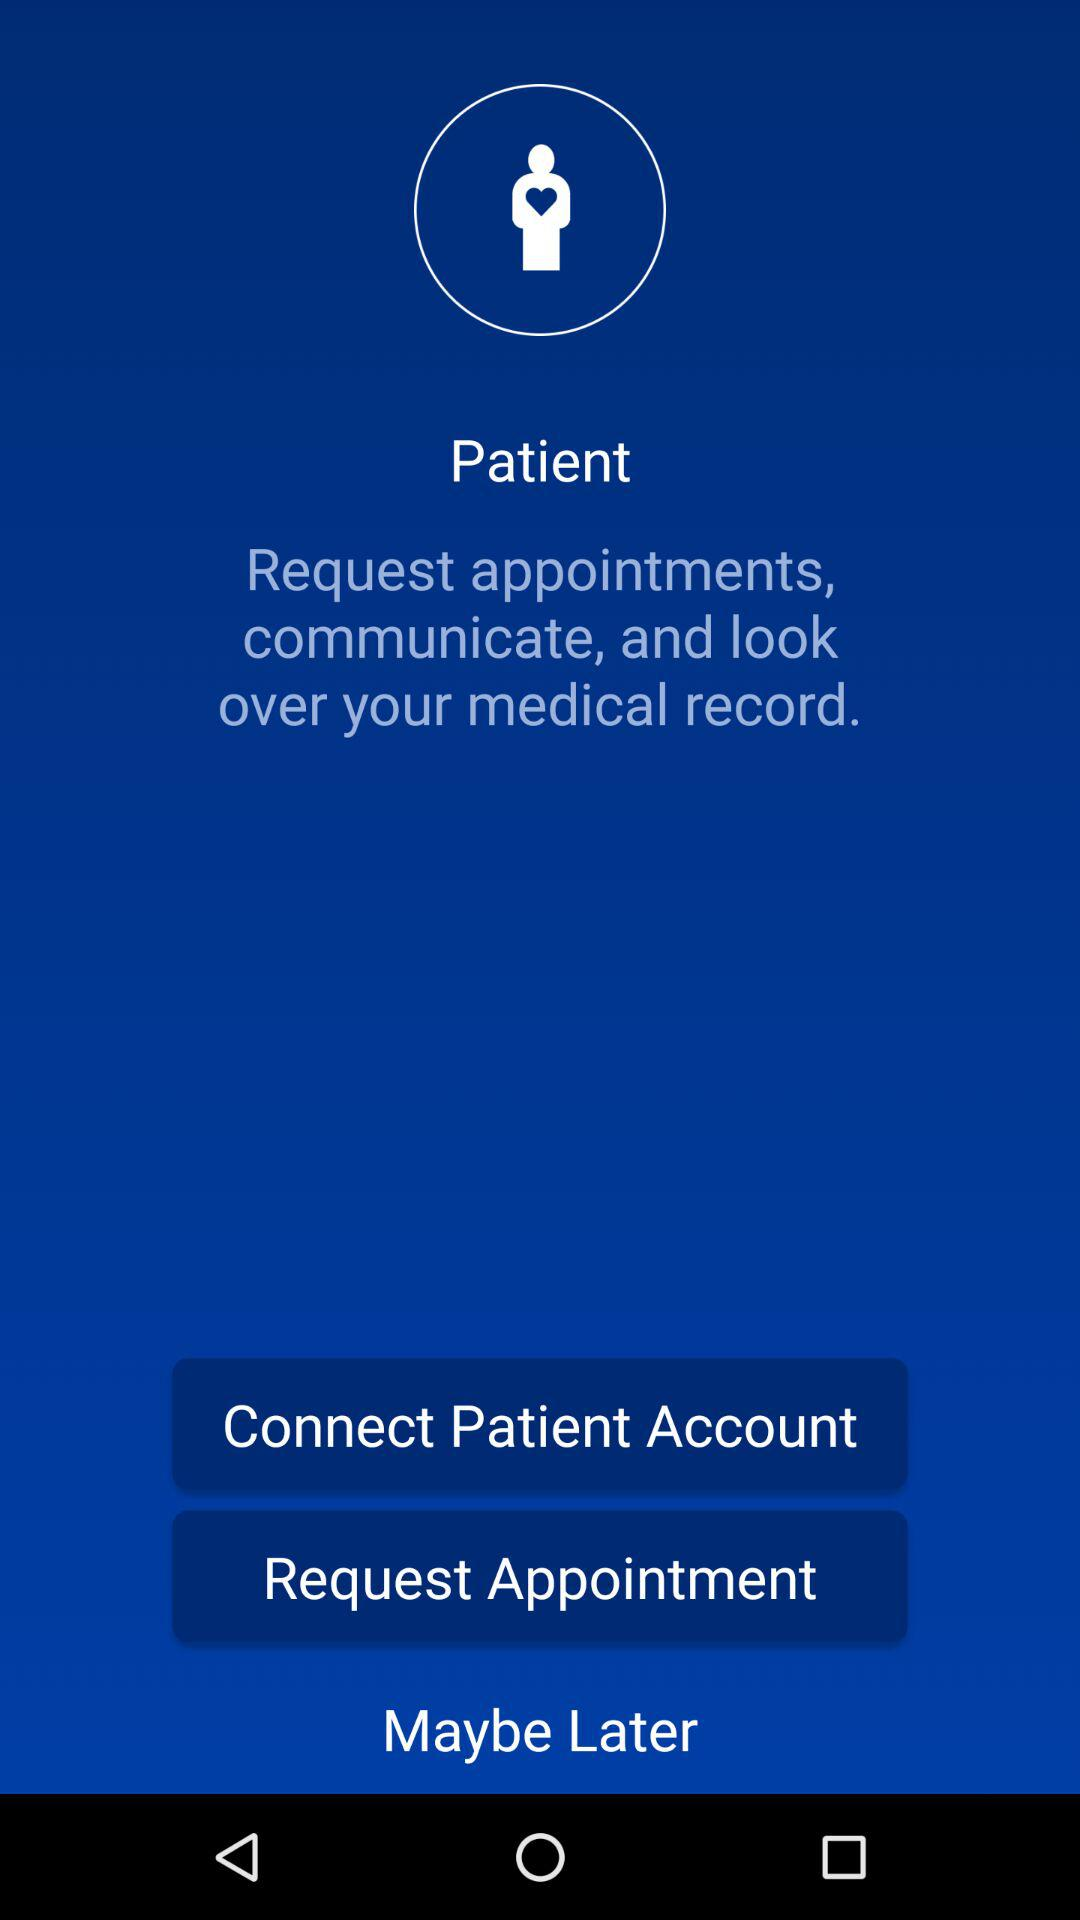What is the name of the application? The name of the application is "Patient". 